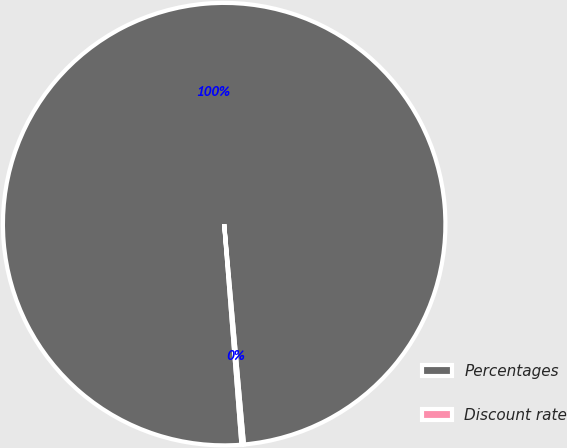Convert chart to OTSL. <chart><loc_0><loc_0><loc_500><loc_500><pie_chart><fcel>Percentages<fcel>Discount rate<nl><fcel>99.82%<fcel>0.18%<nl></chart> 